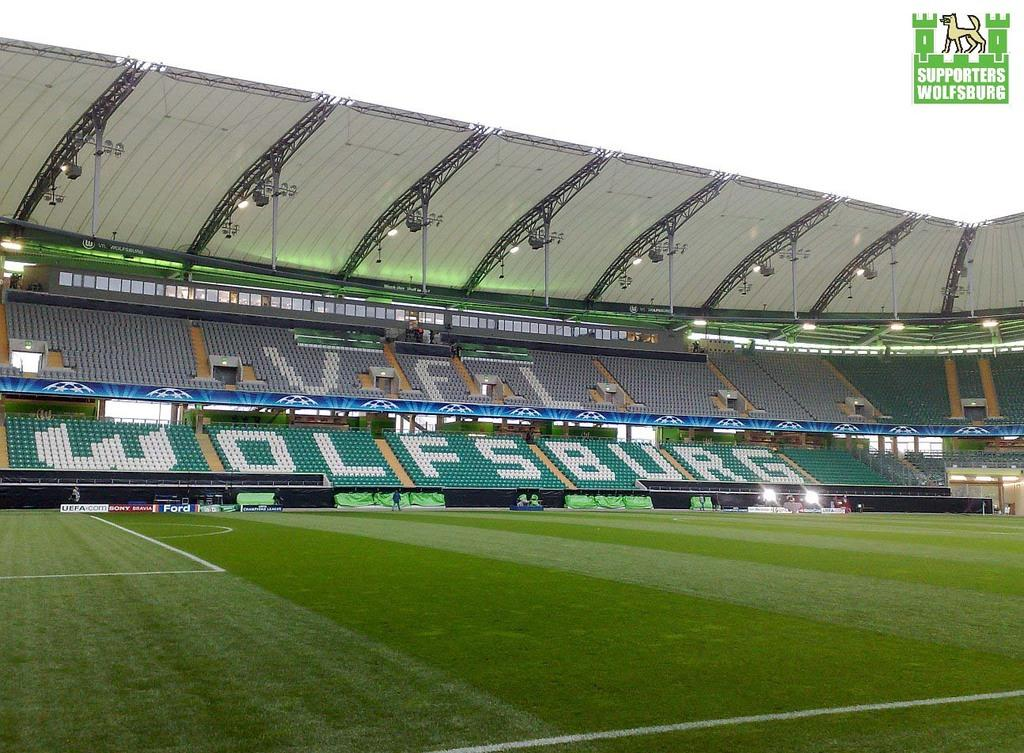<image>
Relay a brief, clear account of the picture shown. Wolfsburg has its name in white seats in their soccer stadium. 